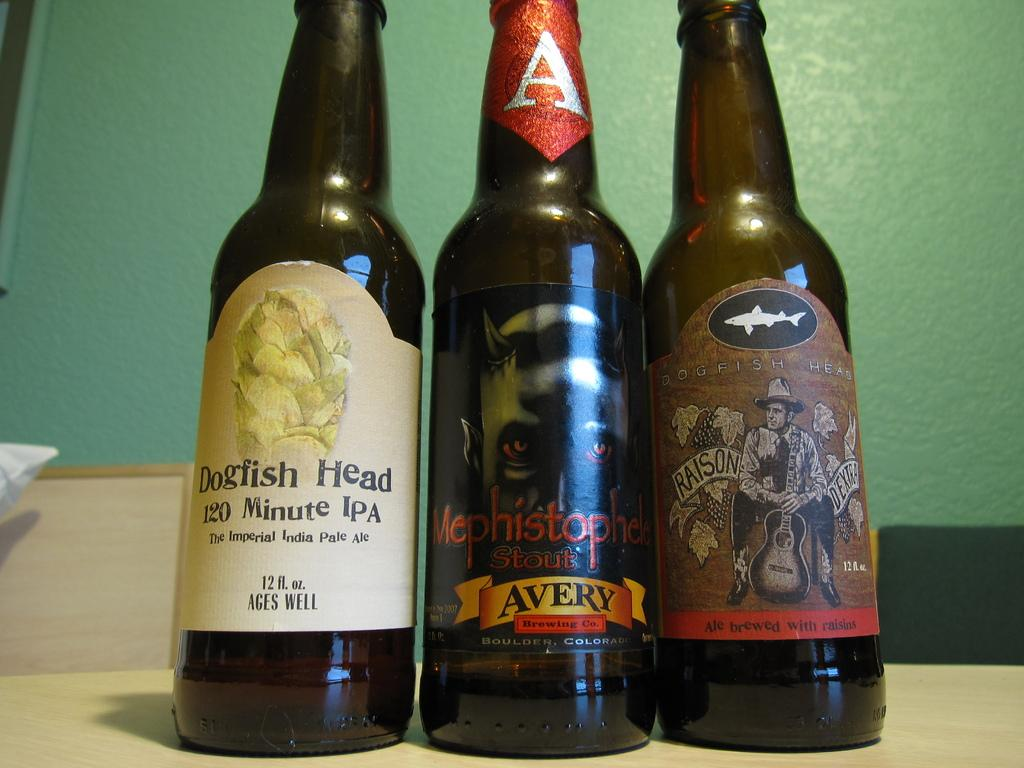<image>
Give a short and clear explanation of the subsequent image. Three bottles of beer on the table the middle one is a bottle of Avery. 